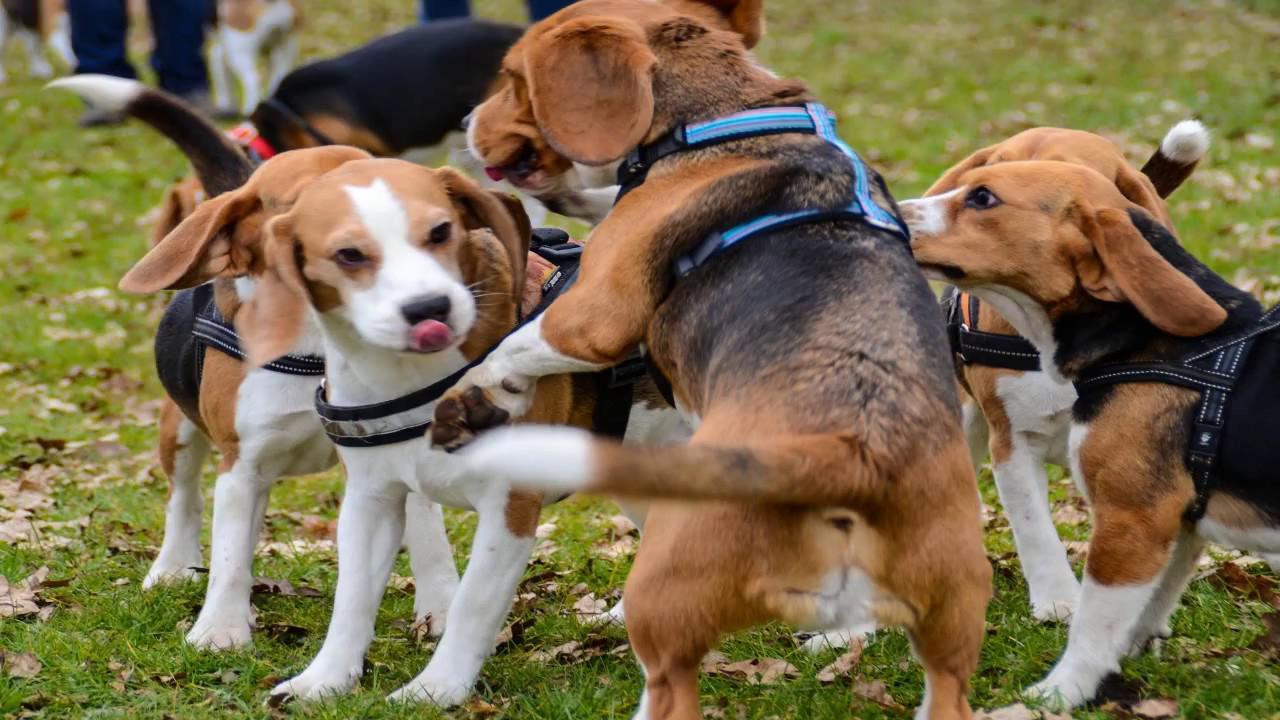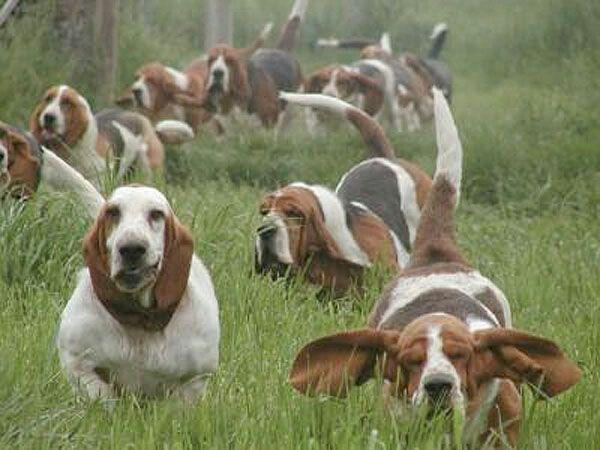The first image is the image on the left, the second image is the image on the right. Examine the images to the left and right. Is the description "Exactly three bassett hounds are pictured, two of them side by side." accurate? Answer yes or no. No. The first image is the image on the left, the second image is the image on the right. Analyze the images presented: Is the assertion "There are three dogs" valid? Answer yes or no. No. 